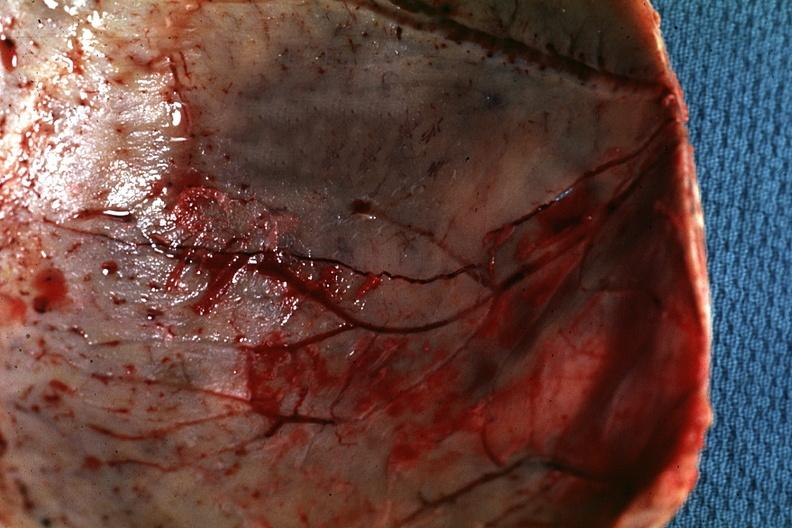how is fracture line shown very skull eggshell type?
Answer the question using a single word or phrase. Thin 